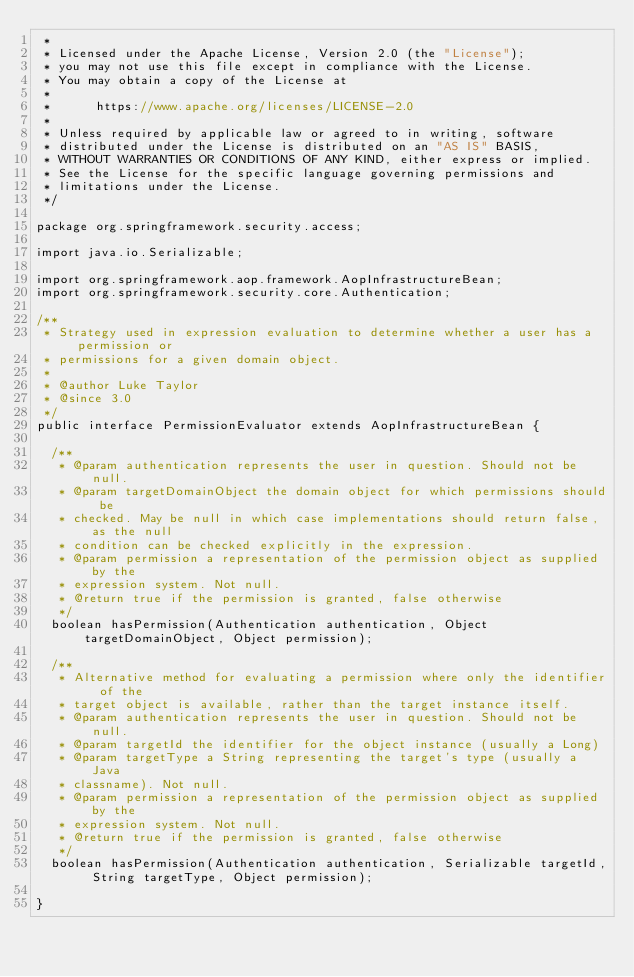Convert code to text. <code><loc_0><loc_0><loc_500><loc_500><_Java_> *
 * Licensed under the Apache License, Version 2.0 (the "License");
 * you may not use this file except in compliance with the License.
 * You may obtain a copy of the License at
 *
 *      https://www.apache.org/licenses/LICENSE-2.0
 *
 * Unless required by applicable law or agreed to in writing, software
 * distributed under the License is distributed on an "AS IS" BASIS,
 * WITHOUT WARRANTIES OR CONDITIONS OF ANY KIND, either express or implied.
 * See the License for the specific language governing permissions and
 * limitations under the License.
 */

package org.springframework.security.access;

import java.io.Serializable;

import org.springframework.aop.framework.AopInfrastructureBean;
import org.springframework.security.core.Authentication;

/**
 * Strategy used in expression evaluation to determine whether a user has a permission or
 * permissions for a given domain object.
 *
 * @author Luke Taylor
 * @since 3.0
 */
public interface PermissionEvaluator extends AopInfrastructureBean {

	/**
	 * @param authentication represents the user in question. Should not be null.
	 * @param targetDomainObject the domain object for which permissions should be
	 * checked. May be null in which case implementations should return false, as the null
	 * condition can be checked explicitly in the expression.
	 * @param permission a representation of the permission object as supplied by the
	 * expression system. Not null.
	 * @return true if the permission is granted, false otherwise
	 */
	boolean hasPermission(Authentication authentication, Object targetDomainObject, Object permission);

	/**
	 * Alternative method for evaluating a permission where only the identifier of the
	 * target object is available, rather than the target instance itself.
	 * @param authentication represents the user in question. Should not be null.
	 * @param targetId the identifier for the object instance (usually a Long)
	 * @param targetType a String representing the target's type (usually a Java
	 * classname). Not null.
	 * @param permission a representation of the permission object as supplied by the
	 * expression system. Not null.
	 * @return true if the permission is granted, false otherwise
	 */
	boolean hasPermission(Authentication authentication, Serializable targetId, String targetType, Object permission);

}
</code> 